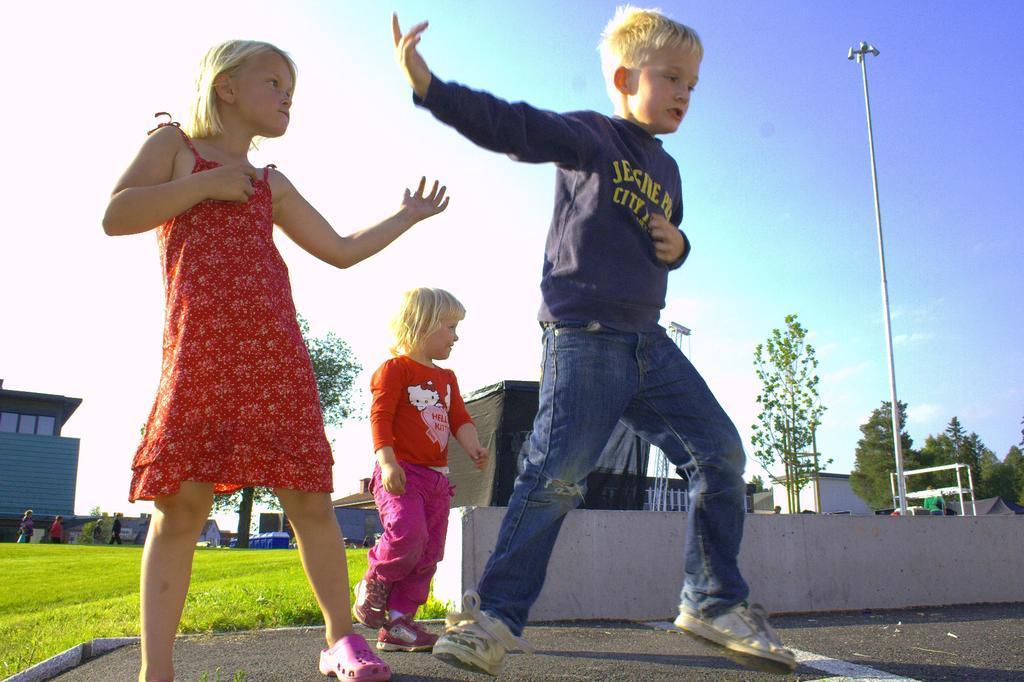Could you give a brief overview of what you see in this image? This image is taken outdoors. At the top of the image there is the sky. At the bottom of the image there is a road and there is a ground with grass on it. In the background there are a few trees with green leaves, stems and branches. There are a few houses with walls, windows and roofs. There is a pole with a street light. A few people are walking on the ground. In the middle of the image three kids are standing on the road and they are performing. 